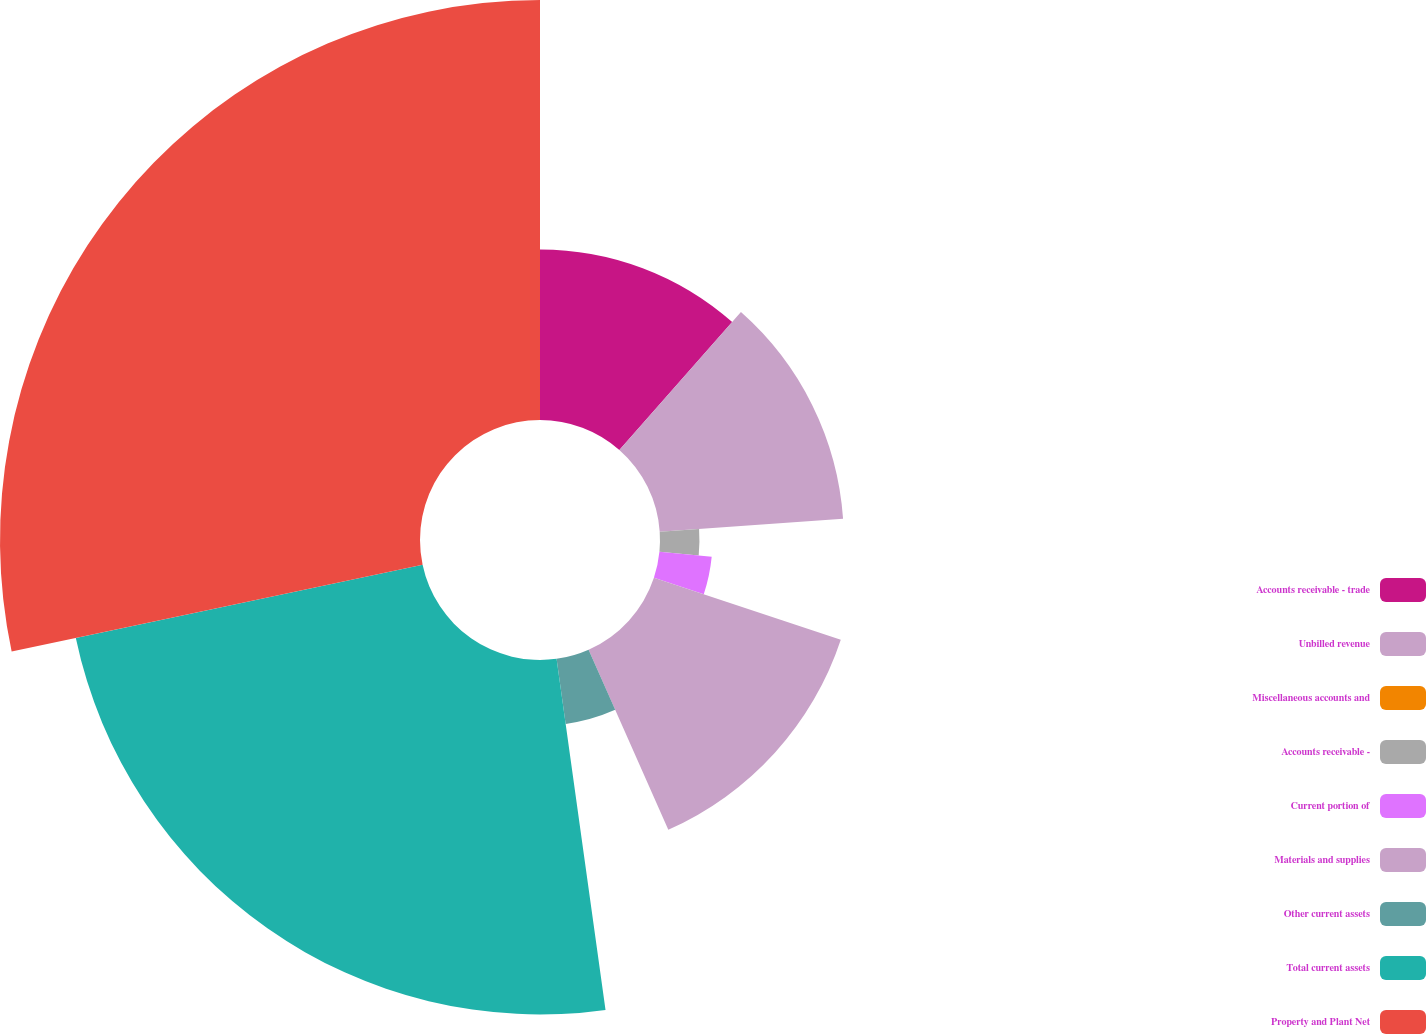Convert chart. <chart><loc_0><loc_0><loc_500><loc_500><pie_chart><fcel>Accounts receivable - trade<fcel>Unbilled revenue<fcel>Miscellaneous accounts and<fcel>Accounts receivable -<fcel>Current portion of<fcel>Materials and supplies<fcel>Other current assets<fcel>Total current assets<fcel>Property and Plant Net<nl><fcel>11.5%<fcel>12.39%<fcel>0.0%<fcel>2.66%<fcel>3.54%<fcel>13.27%<fcel>4.43%<fcel>23.89%<fcel>28.31%<nl></chart> 